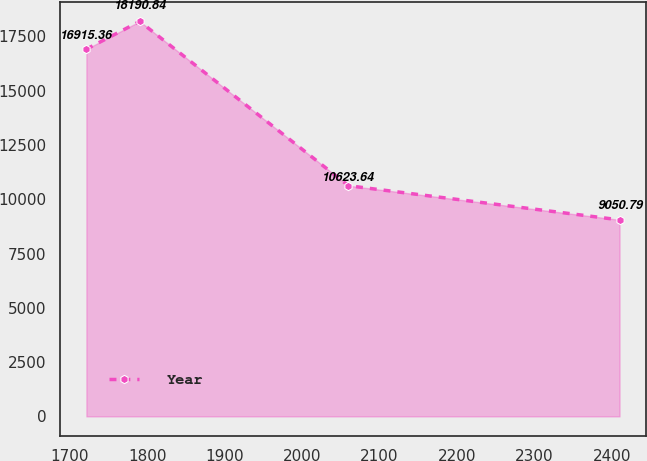<chart> <loc_0><loc_0><loc_500><loc_500><line_chart><ecel><fcel>Year<nl><fcel>1721.69<fcel>16915.4<nl><fcel>1790.49<fcel>18190.8<nl><fcel>2059.84<fcel>10623.6<nl><fcel>2409.66<fcel>9050.79<nl></chart> 